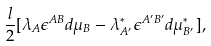Convert formula to latex. <formula><loc_0><loc_0><loc_500><loc_500>\frac { l } { 2 } [ \lambda _ { A } \epsilon ^ { A B } d \mu _ { B } - \lambda ^ { * } _ { A ^ { \prime } } \epsilon ^ { A ^ { \prime } B ^ { \prime } } d \mu ^ { * } _ { B ^ { \prime } } ] ,</formula> 